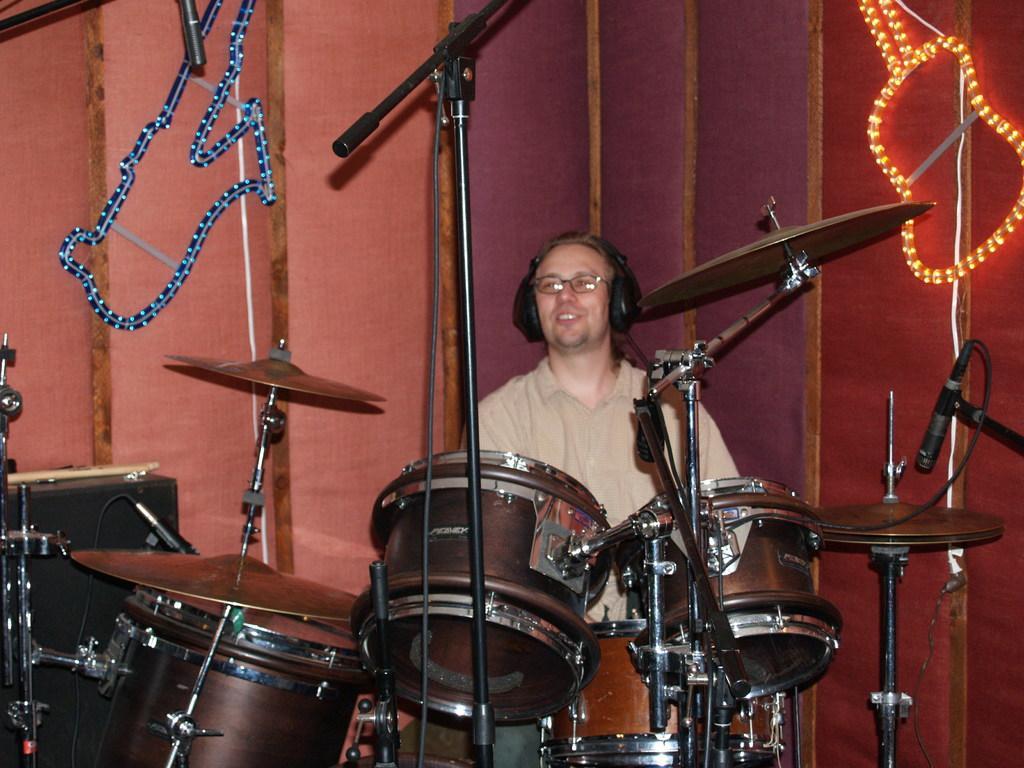In one or two sentences, can you explain what this image depicts? In this image I can see a person is playing musical instruments. In the background I can see lights and curtains. This image is taken on the stage. 